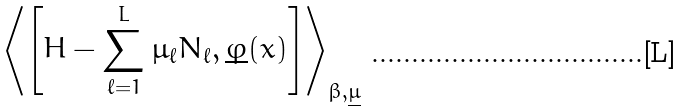Convert formula to latex. <formula><loc_0><loc_0><loc_500><loc_500>\left \langle \left [ H - \sum _ { \ell = 1 } ^ { L } \mu _ { \ell } N _ { \ell } , \underline { \varphi } ( x ) \right ] \right \rangle _ { \beta , \underline { \mu } }</formula> 